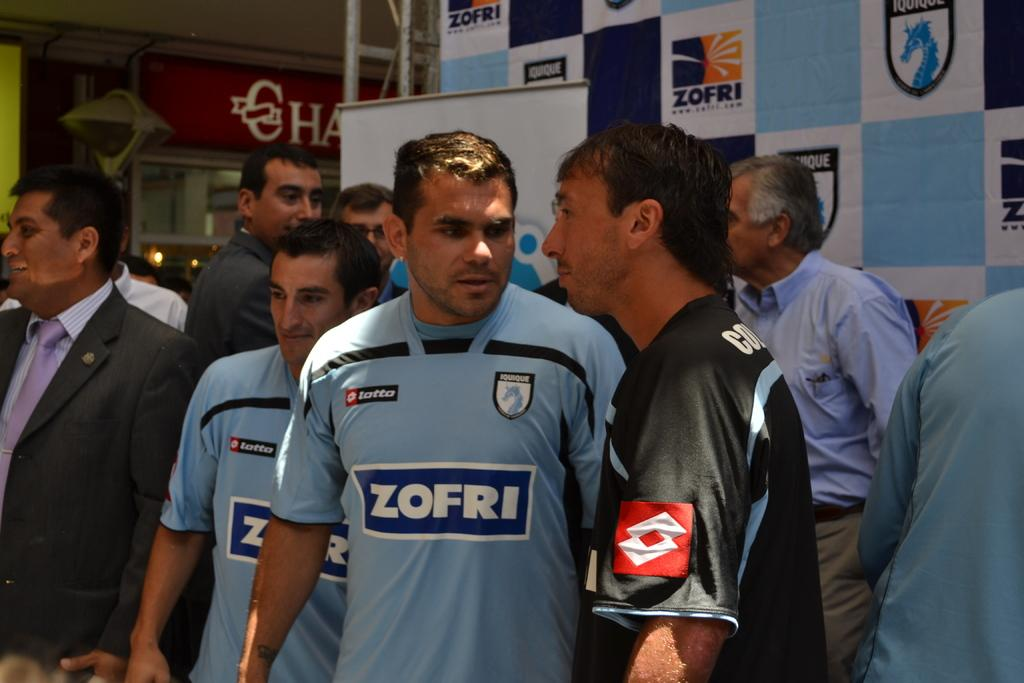<image>
Relay a brief, clear account of the picture shown. Athlete in blue with ZOFRI on the front standing next to an athlete in a black jersey. 